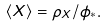Convert formula to latex. <formula><loc_0><loc_0><loc_500><loc_500>\langle X \rangle = \rho _ { X } / \phi _ { * } .</formula> 